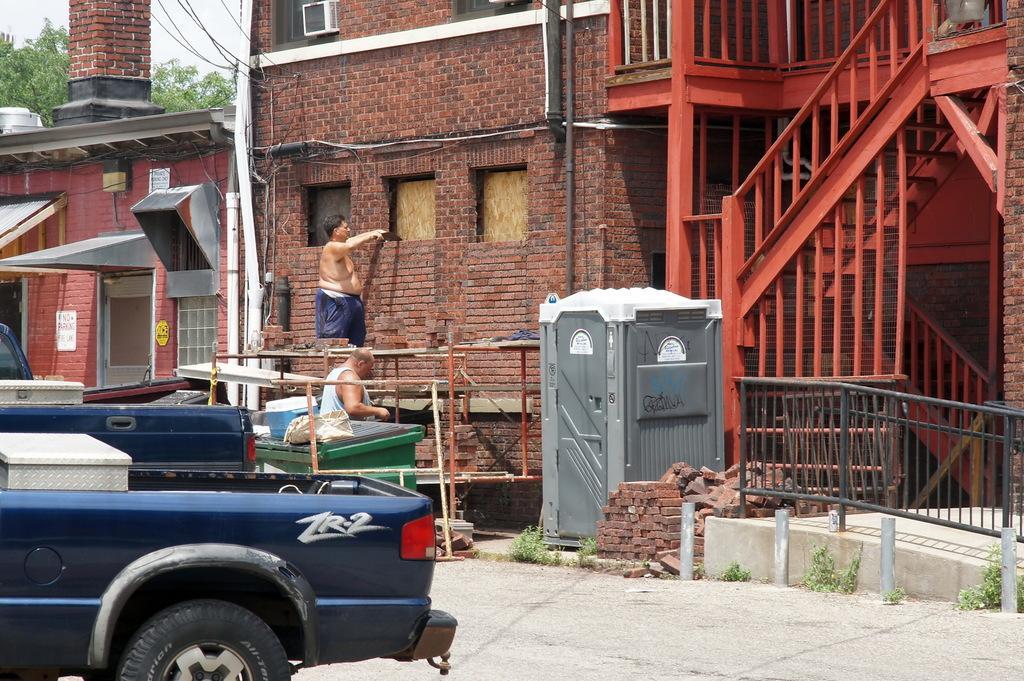Can you describe this image briefly? In this picture I can observe two men. One of them is working on the wall. On the left side I can observe two vehicles and a house. On the right side I can observe red color stairs and a building. In the background there are trees and a sky. 